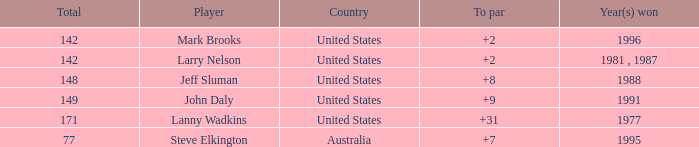Name the To par that has a Year(s) won of 1988 and a Total smaller than 148? None. 